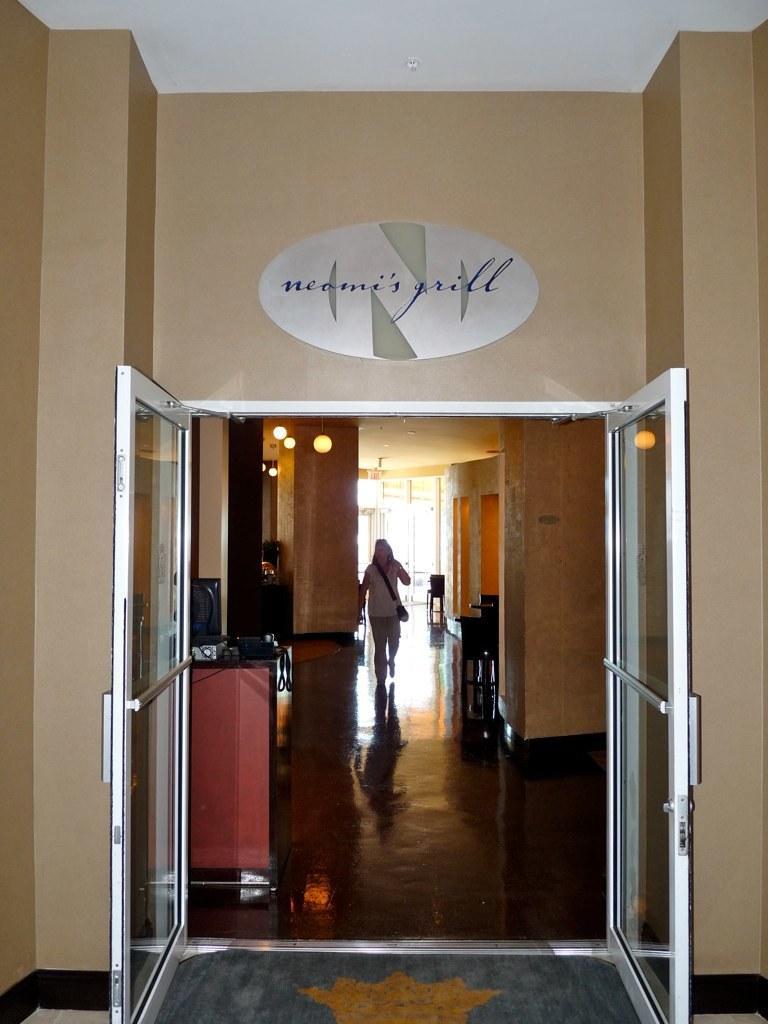In one or two sentences, can you explain what this image depicts? In the image there is a wall with glass doors. Inside the room on the left side there table with monitor and some other items. There is a person walking on the floor. There are few lamps are hanging on the roof. And also there are pillars, walls and some other items in the background. At the bottom of the image there is a doormat. 